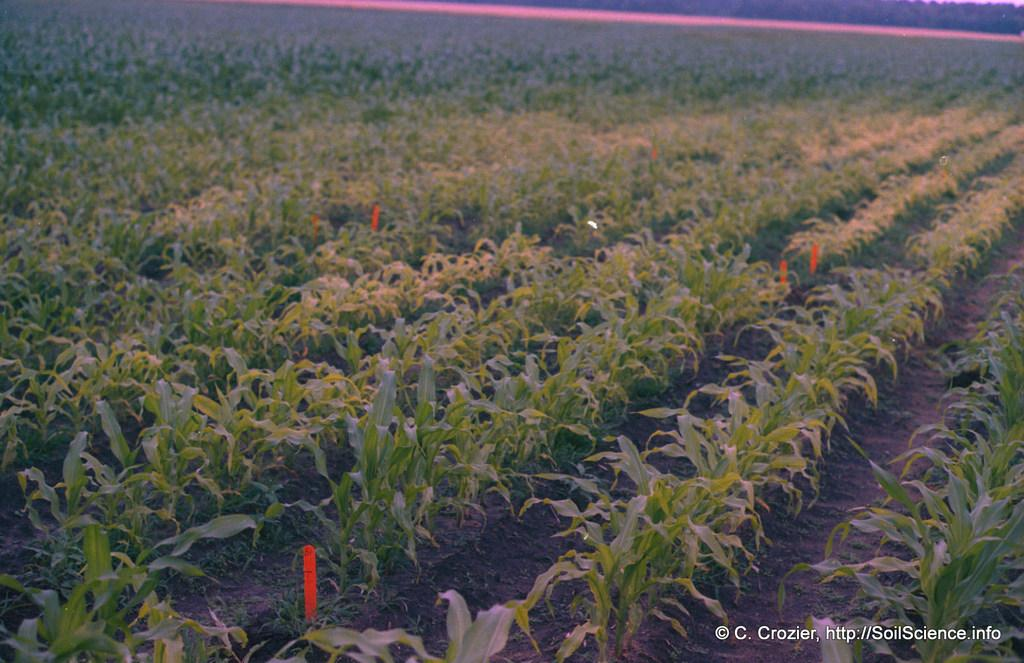What type of vegetation is present in the image? There is grass in the image. What type of ground is visible in the image? There is soil in the image. Where is the water mark located in the image? The water mark is at the right bottom of the image. How many yaks can be seen grazing on the grass in the image? There are no yaks present in the image; it only features grass and soil. What type of jelly is being used to hold the soil together in the image? There is no jelly present in the image; it only features grass and soil. 